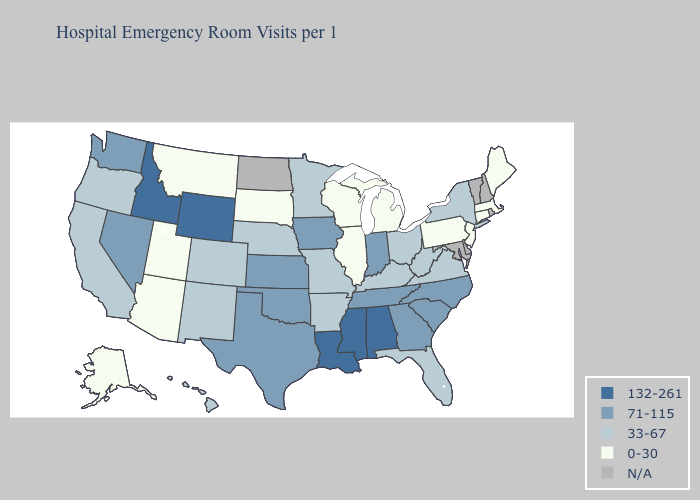What is the lowest value in states that border Georgia?
Keep it brief. 33-67. Does Mississippi have the highest value in the South?
Answer briefly. Yes. Which states have the highest value in the USA?
Keep it brief. Alabama, Idaho, Louisiana, Mississippi, Wyoming. Among the states that border Arkansas , does Louisiana have the lowest value?
Write a very short answer. No. Among the states that border Arizona , which have the lowest value?
Answer briefly. Utah. What is the value of Iowa?
Concise answer only. 71-115. Among the states that border Montana , which have the lowest value?
Answer briefly. South Dakota. What is the value of Hawaii?
Give a very brief answer. 33-67. Which states hav the highest value in the MidWest?
Concise answer only. Indiana, Iowa, Kansas. Among the states that border Montana , which have the lowest value?
Answer briefly. South Dakota. Name the states that have a value in the range 0-30?
Concise answer only. Alaska, Arizona, Connecticut, Illinois, Maine, Massachusetts, Michigan, Montana, New Jersey, Pennsylvania, South Dakota, Utah, Wisconsin. What is the value of Minnesota?
Keep it brief. 33-67. What is the lowest value in the USA?
Answer briefly. 0-30. 